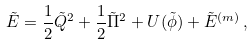<formula> <loc_0><loc_0><loc_500><loc_500>\tilde { E } = \frac { 1 } { 2 } \tilde { Q } ^ { 2 } + \frac { 1 } { 2 } \tilde { \Pi } ^ { 2 } + U ( \tilde { \phi } ) + \tilde { E } ^ { ( m ) } \, ,</formula> 